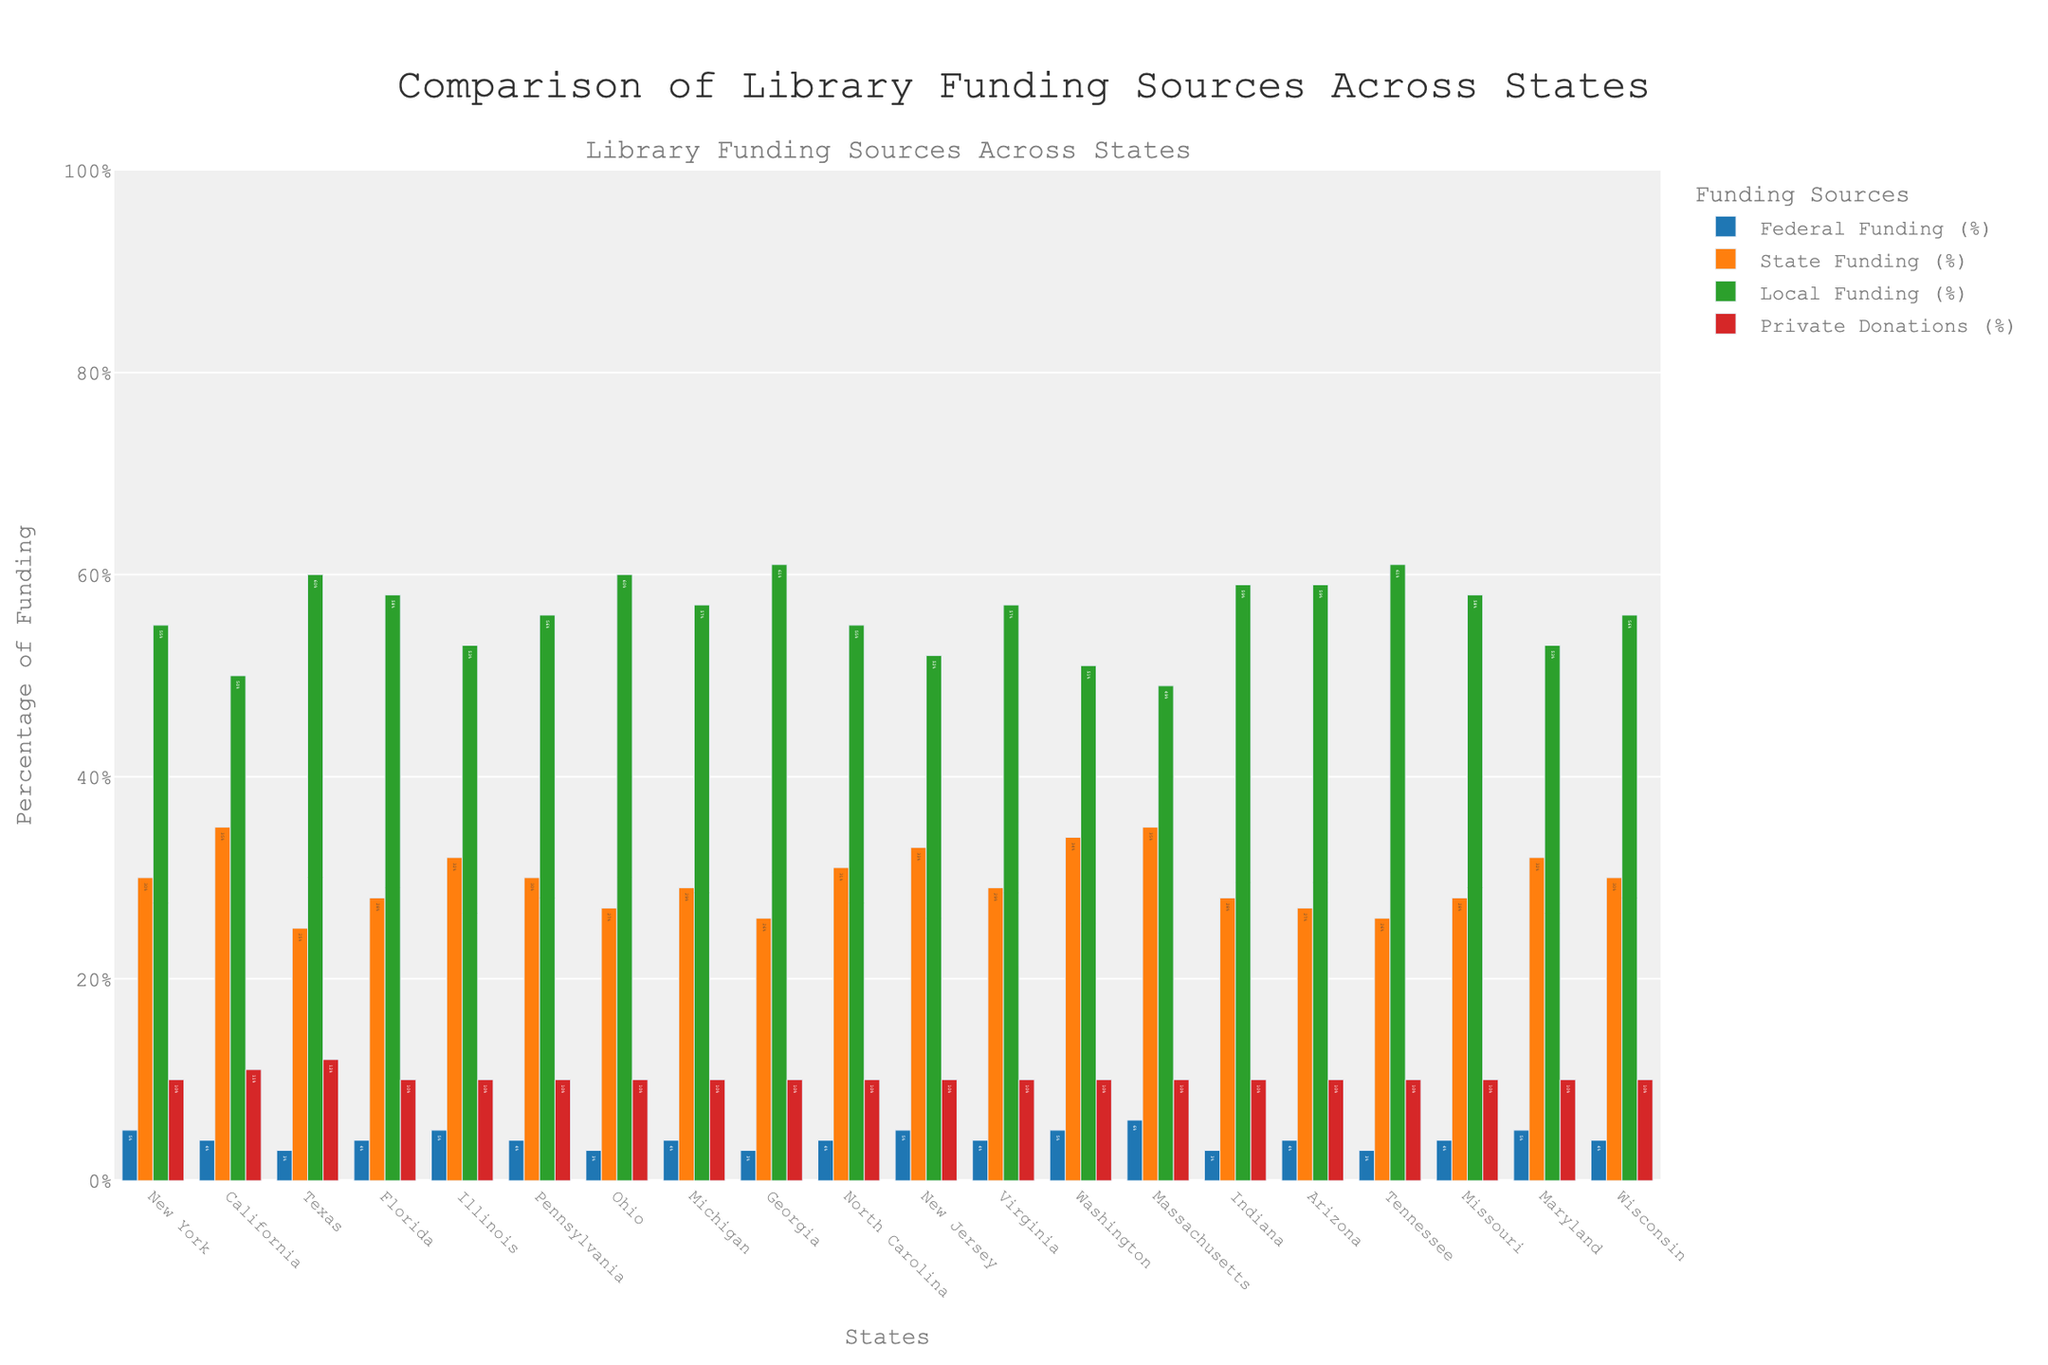What's the state with the highest percentage of local funding for libraries? The state with the highest percentage of local funding for libraries is the one with the tallest green bar in the local funding category. In the figure, Georgia has the highest local funding percentage at 61%.
Answer: Georgia Which two states have the same percentage of private donations for library funding? Look at the red bars representing private donations. The states with bars of the same height and percentage value for private donations are New York, Illinois, Pennsylvania, Ohio, North Carolina, Virginia, and several others, all at 10%.
Answer: Several states, including New York and Illinois What is the difference in state funding percentages between New York and California? Find the height of the orange bars for state funding for both New York and California. New York has 30% state funding, and California has 35%. Calculate the difference: 35% - 30% = 5%.
Answer: 5% Which state has the highest percentage of federal funding and what is that percentage? Identify the tallest blue bar representing federal funding. Massachusetts has the highest percentage for federal funding at 6%.
Answer: Massachusetts, 6% Calculate the average federal funding percentage across all states. Sum the percentages of federal funding for all states: (5 + 4 + 3 + 4 + 5 + 4 + 3 + 4 + 3 + 4 + 5 + 4 + 5 + 6 + 3 + 4 + 3 + 4 + 5 + 4). The total is 81. Then divide by the number of states (20): 81/20 = 4.05%.
Answer: 4.05% What is the total percentage of the combined funding sources for Florida? Add the percentages of all funding sources together for Florida: Federal (4%) + State (28%) + Local (58%) + Private (10%) = 100%.
Answer: 100% Compare the local funding percentages between Arizona and Ohio. Which state has a higher percentage, and by how much? Look at the green bars for local funding in both states. Arizona has 59% local funding, and Ohio has 60%. The difference is: 60% - 59% = 1%.
Answer: Ohio by 1% Which states have a federal funding percentage below 5%? Identify the states with blue bars shorter than the 5% mark. The states with a federal funding percentage below 5% are California, Texas, Florida, Ohio, Georgia, North Carolina, Pennsylvania, Virginia, Michigan, Indiana, Tennessee, and Arizona.
Answer: Multiple states including California and Texas Among New York, California, and Texas, which state has the highest percentage of state funding? Compare the height of the orange bars for state funding among New York (30%), California (35%), and Texas (25%). California has the highest percentage of state funding at 35%.
Answer: California, 35% In which state does federal funding contribute the same percentage as state funding? Look for states where the height of the blue bar (federal) and the orange bar (state) are equal. No state has identical percentages for federal and state funding.
Answer: None 